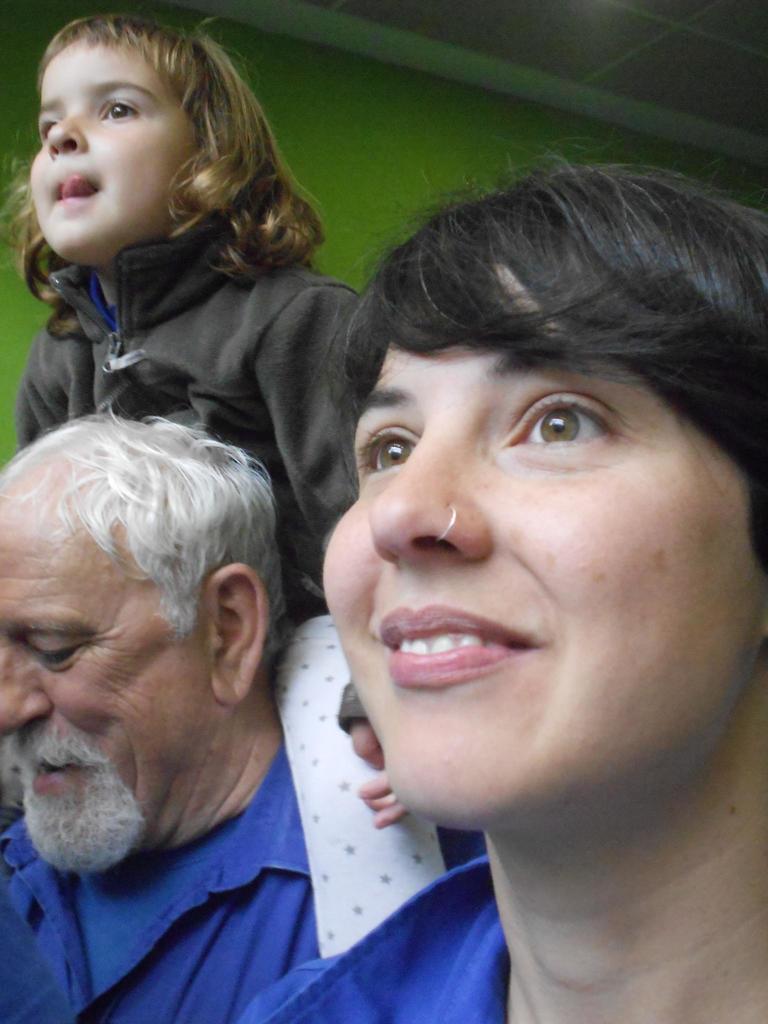Can you describe this image briefly? In this image there is a woman towards the right of the image, there is a man towards the left of the image, there is a girl sitting on the man, at the background of the image there is a green color wall. 